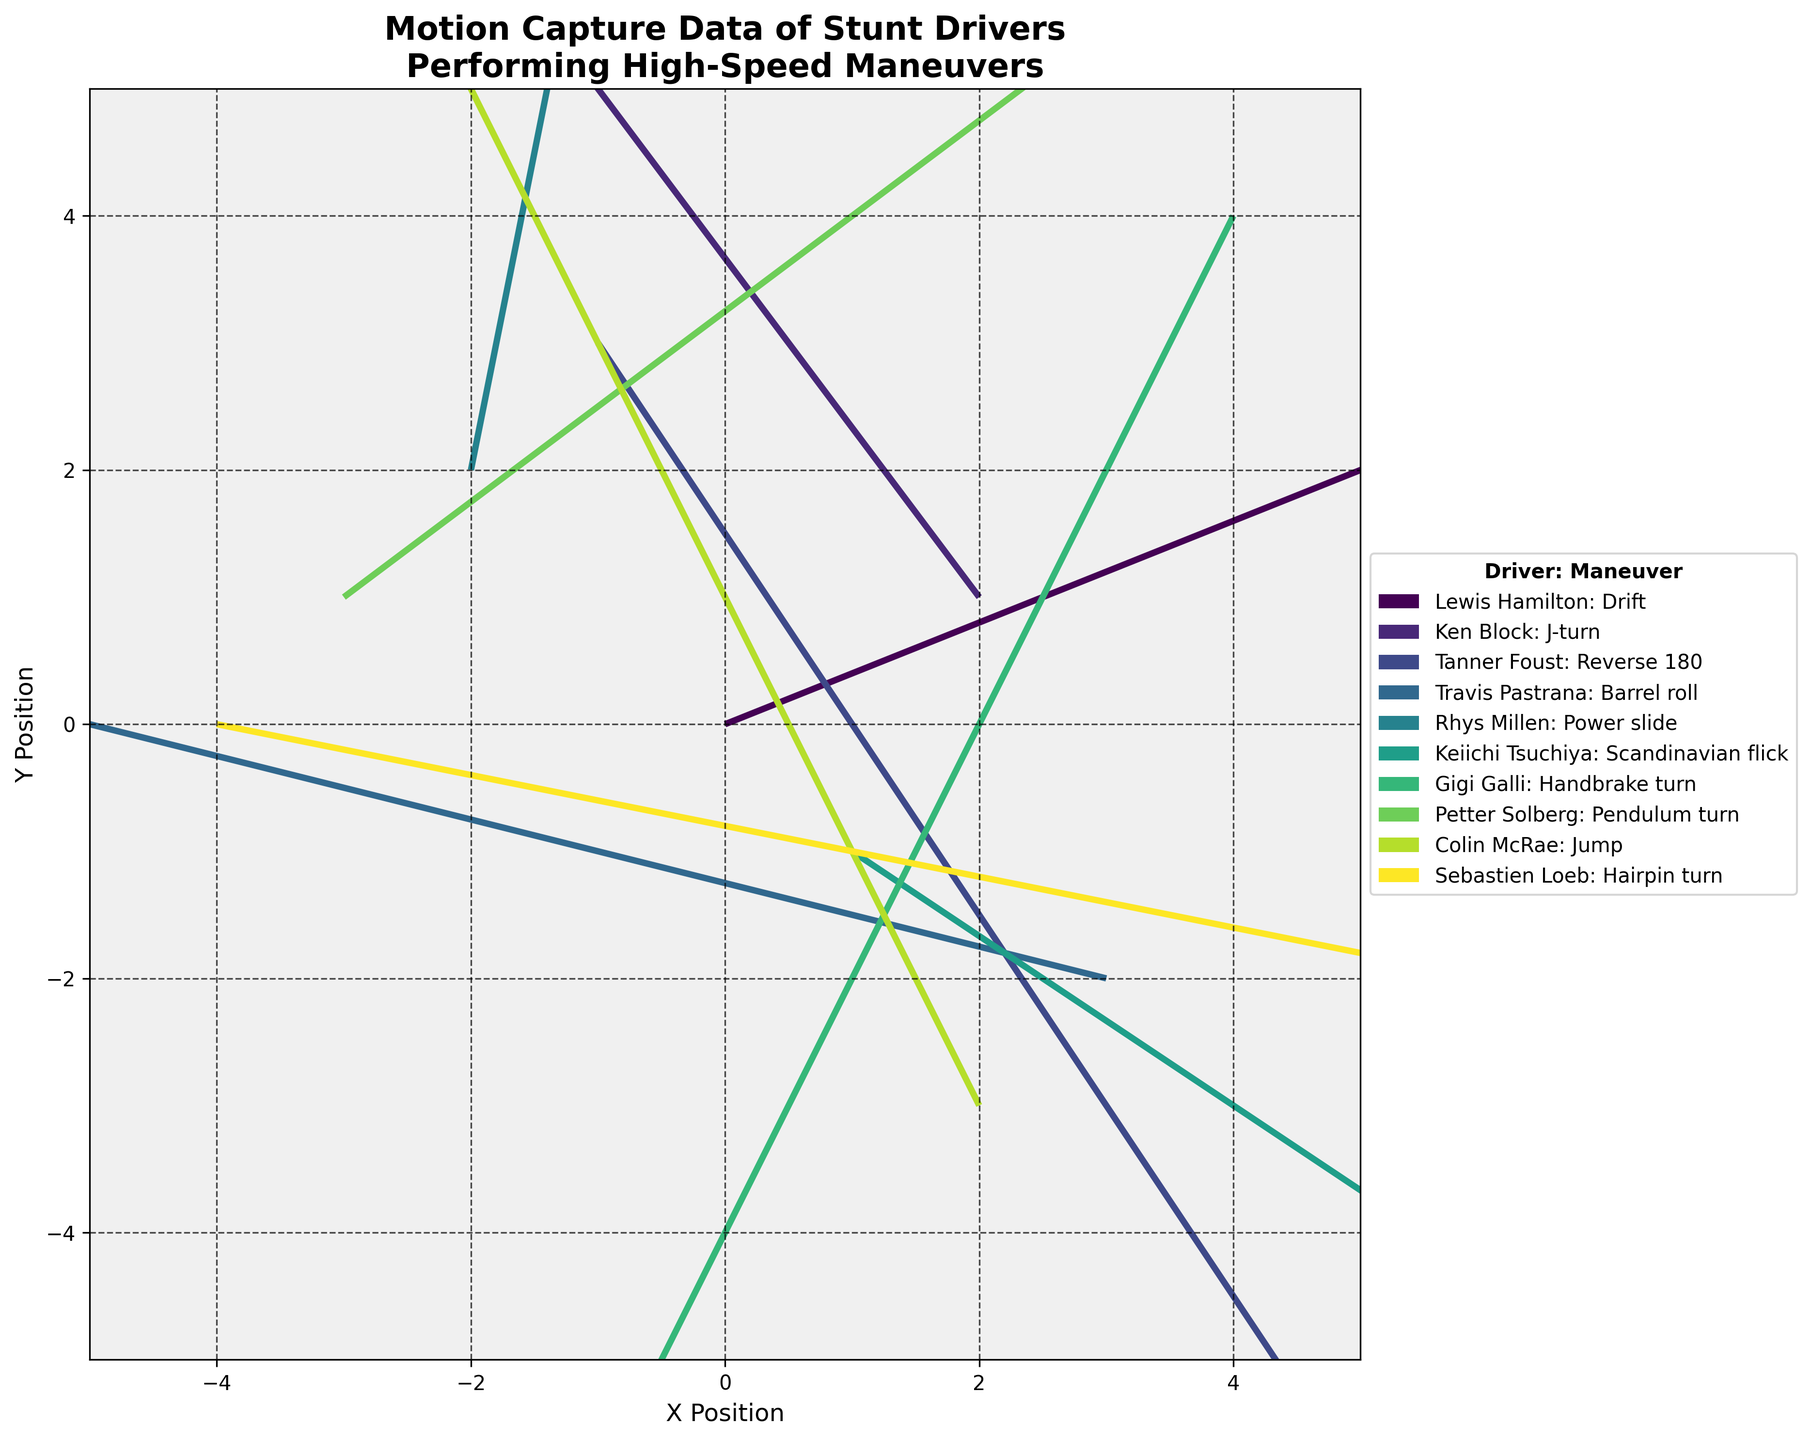What is the title of the plot? The title is prominently displayed at the top of the figure. It reads, "Motion Capture Data of Stunt Drivers Performing High-Speed Maneuvers."
Answer: Motion Capture Data of Stunt Drivers Performing High-Speed Maneuvers What are the x and y limits of the plot? The x and y limits are indicated by the axis ranges. They both range from -5 to 5.
Answer: -5 to 5 Which driver performed the 'Handbrake turn' maneuver? Each quiver arrow is color-coded and labeled with the driver and their maneuver. The one labeled "Gigi Galli: Handbrake turn" indicates Gigi Galli performed the handbrake turn.
Answer: Gigi Galli How many drivers performed maneuvers in the negative x direction? We need to count the number of drivers with a negative value in the 'u' column. There are four such drivers: Ken Block, Travis Pastrana, Colin McRae, and Gigi Galli.
Answer: Four drivers What is the total change in the y direction for 'Drift' and 'J-turn'? The total change in the y direction (v) for Drift and J-turn is the sum of their 'v' values. For Drift, v = 2; for J-turn, v = 4. So, the total change is 2 + 4.
Answer: 6 Which driver traveled the farthest distance? To determine the distance, calculate the vector magnitude for each driver. The formula is sqrt(u² + v²). The maximum value indicates the farthest distance. Rhys Millen has the largest value sqrt(1² + 5²) = sqrt(26).
Answer: Rhys Millen What is the average change in the x direction (u) for all drivers? Sum all the 'u' values and divide by the number of drivers. The sum of 'u' is 5 + (-3) + 2 + (-4) + 1 + 3 + (-2) + 4 + (-1) + 5 = 10. There are 10 drivers, so the average is 10/10.
Answer: 1 Which two drivers have opposite x-direction changes? Look for pairs of drivers where one has a positive 'u' value and the other has the corresponding negative 'u' value. Lewis Hamilton (u=5) and Sebastien Loeb (u=-5) are such a pair.
Answer: Lewis Hamilton and Sebastien Loeb What is the median change in the y direction (v)? The 'v' values are 2, 4, -3, 1, 5, -2, -4, 3, 2, -1. Sort them to get -4, -3, -2, -1, 1, 2, 2, 3, 4, 5. The median is the average of the 5th and 6th values (1 and 2).
Answer: 1.5 Which maneuver resulted in the largest net movement in both x and y directions combined? Calculate the net movement using sqrt(u² + v²) for each maneuver. The largest value corresponds to Rhys Millen's maneuver: sqrt(1² + 5²) = sqrt(26).
Answer: Power slide 